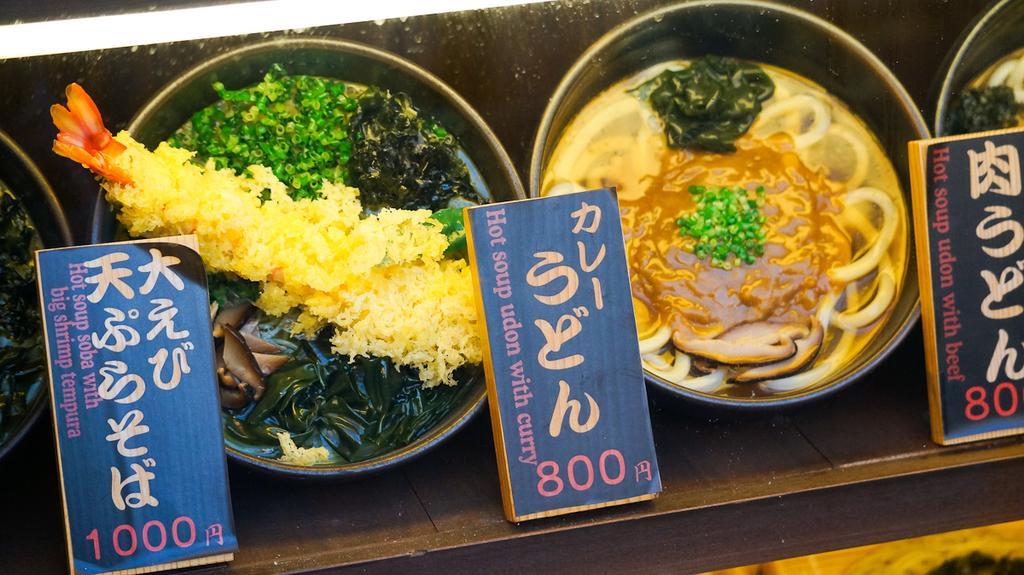Please provide a concise description of this image. In this image, I can see food items in the bowls and there are boards on an object. 